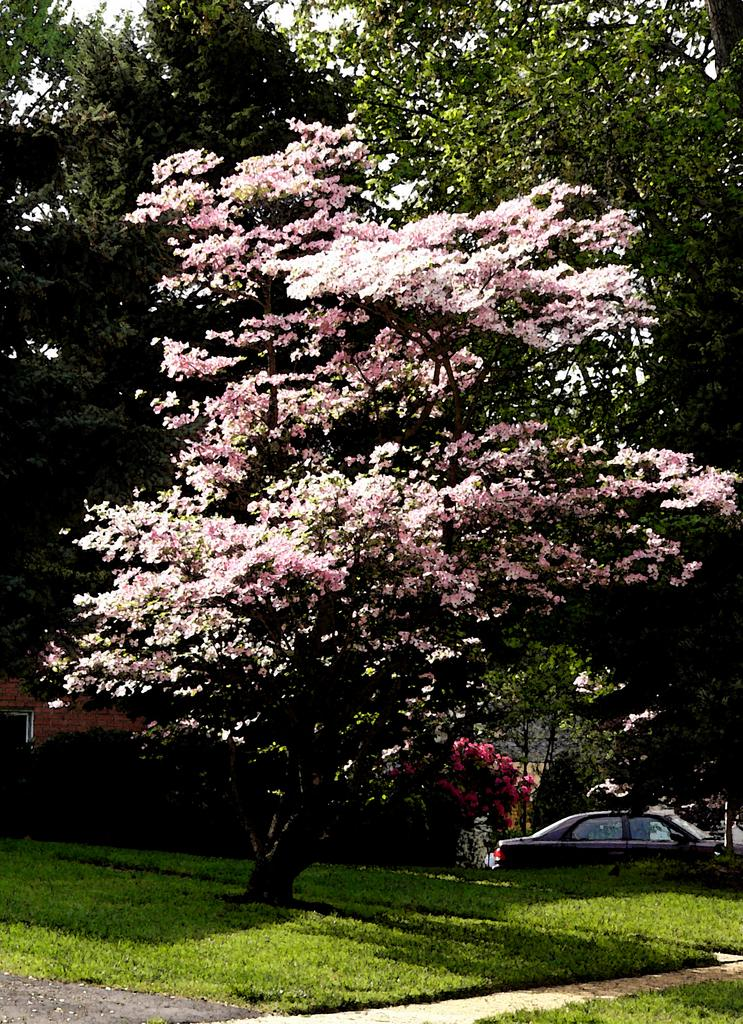What type of vegetation can be seen in the image? There are trees in the image. What else is present in the image besides the trees? There is a vehicle in the image. What is the ground surface like in the image? The ground is visible in the image and is covered with grass. How many cacti can be seen in the image? There are no cacti present in the image; only trees are visible. What type of boot is being worn by the tree in the image? There are no boots or trees wearing boots in the image. 